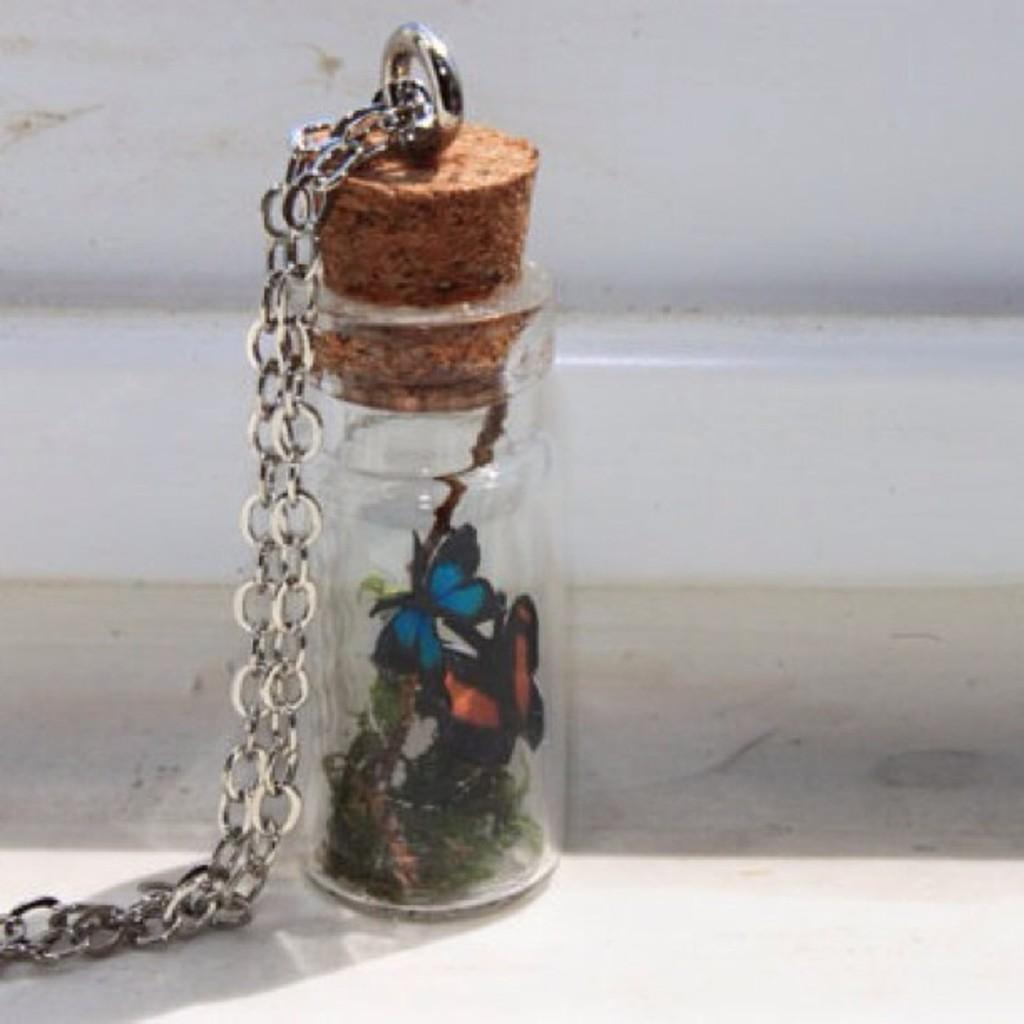What is attached to the bottle in the image? There is a chain attached to the bottle in the image. What can be seen in the background of the image? There is a wall in the background of the image. What is inside the bottle? There are butterflies inside the bottle. What type of screw can be seen on the wall in the image? There is no screw visible on the wall in the image. What type of cream is being used to attract the butterflies in the image? There is no cream present in the image; the butterflies are inside the bottle without any cream. 